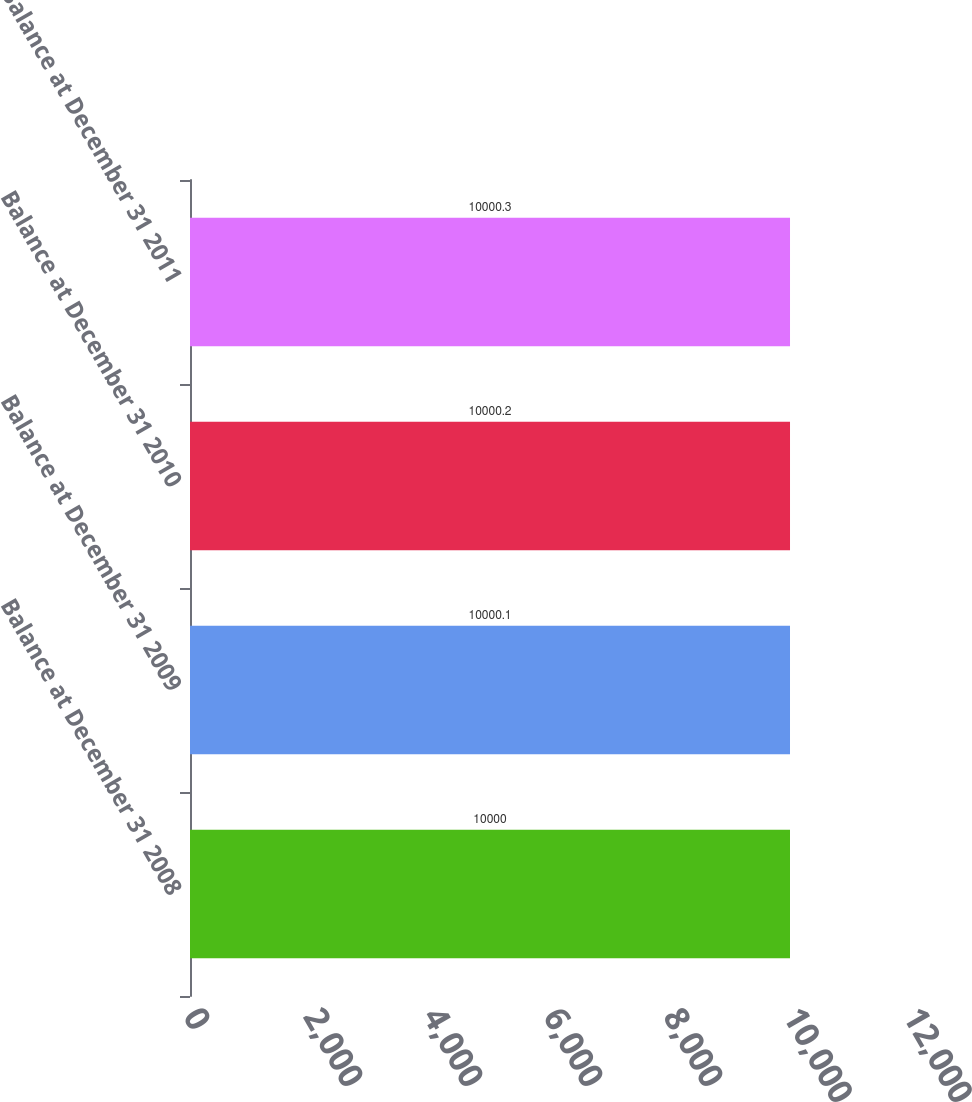<chart> <loc_0><loc_0><loc_500><loc_500><bar_chart><fcel>Balance at December 31 2008<fcel>Balance at December 31 2009<fcel>Balance at December 31 2010<fcel>Balance at December 31 2011<nl><fcel>10000<fcel>10000.1<fcel>10000.2<fcel>10000.3<nl></chart> 